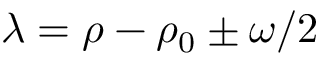Convert formula to latex. <formula><loc_0><loc_0><loc_500><loc_500>\lambda = \rho - \rho _ { 0 } \pm \omega / 2</formula> 